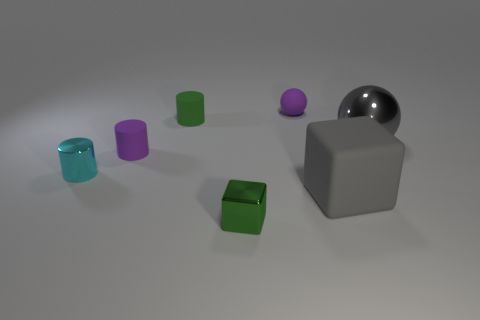Subtract all green balls. Subtract all yellow cubes. How many balls are left? 2 Add 2 large blue metallic blocks. How many objects exist? 9 Subtract all cubes. How many objects are left? 5 Subtract 0 red cylinders. How many objects are left? 7 Subtract all large yellow cubes. Subtract all green metal things. How many objects are left? 6 Add 4 gray rubber objects. How many gray rubber objects are left? 5 Add 3 shiny cylinders. How many shiny cylinders exist? 4 